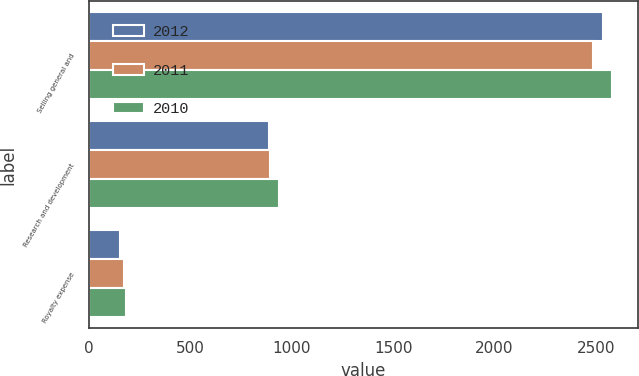Convert chart. <chart><loc_0><loc_0><loc_500><loc_500><stacked_bar_chart><ecel><fcel>Selling general and<fcel>Research and development<fcel>Royalty expense<nl><fcel>2012<fcel>2535<fcel>886<fcel>153<nl><fcel>2011<fcel>2487<fcel>895<fcel>172<nl><fcel>2010<fcel>2580<fcel>939<fcel>185<nl></chart> 